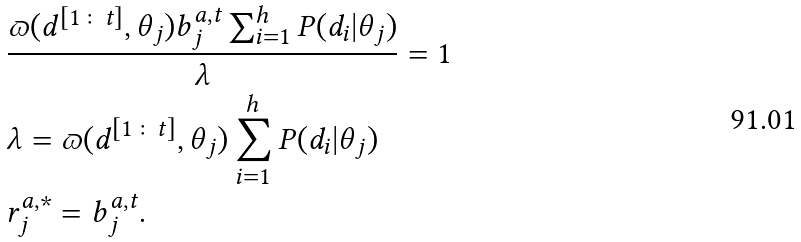Convert formula to latex. <formula><loc_0><loc_0><loc_500><loc_500>& \frac { \varpi ( d ^ { [ 1 \colon t ] } , \theta _ { j } ) b _ { j } ^ { a , t } \sum _ { i = 1 } ^ { h } P ( d _ { i } | \theta _ { j } ) } { \lambda } = 1 \\ & \lambda = \varpi ( d ^ { [ 1 \colon t ] } , \theta _ { j } ) \sum _ { i = 1 } ^ { h } P ( d _ { i } | \theta _ { j } ) \\ & r _ { j } ^ { a , * } = b _ { j } ^ { a , t } .</formula> 